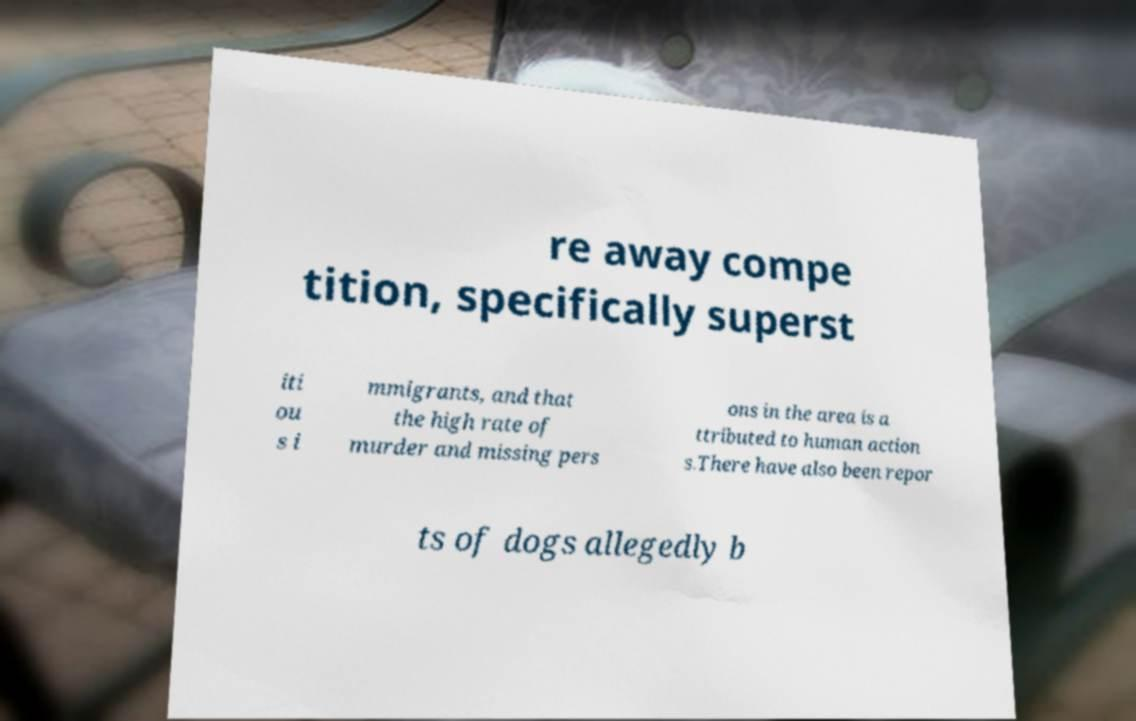Could you assist in decoding the text presented in this image and type it out clearly? re away compe tition, specifically superst iti ou s i mmigrants, and that the high rate of murder and missing pers ons in the area is a ttributed to human action s.There have also been repor ts of dogs allegedly b 